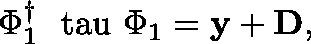Convert formula to latex. <formula><loc_0><loc_0><loc_500><loc_500>\Phi _ { 1 } ^ { \dagger } \boldmath \ t a u \Phi _ { 1 } = { y } + { D } ,</formula> 